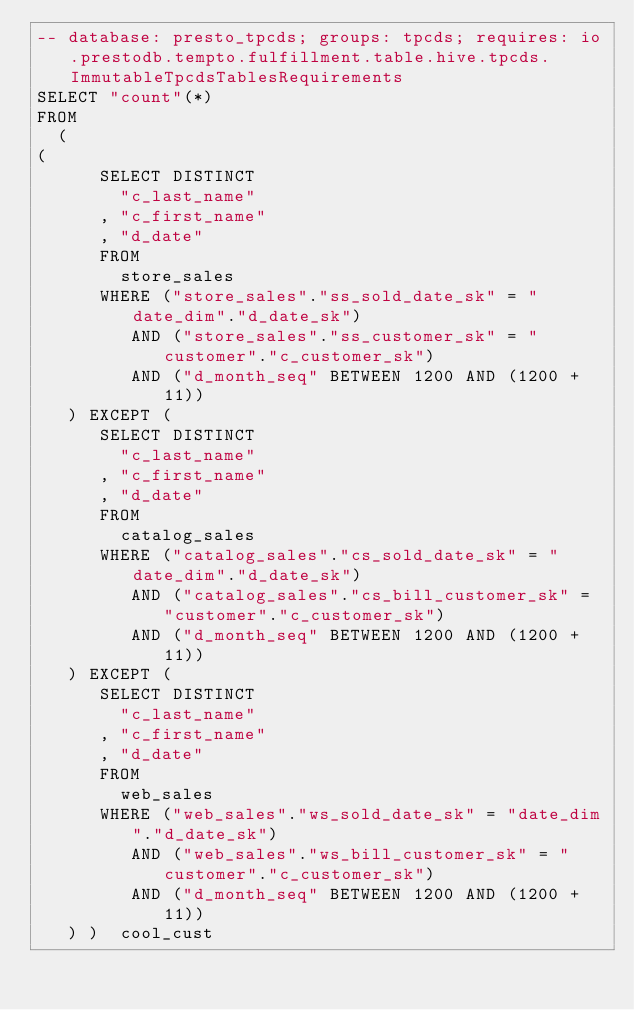Convert code to text. <code><loc_0><loc_0><loc_500><loc_500><_SQL_>-- database: presto_tpcds; groups: tpcds; requires: io.prestodb.tempto.fulfillment.table.hive.tpcds.ImmutableTpcdsTablesRequirements
SELECT "count"(*)
FROM
  (
(
      SELECT DISTINCT
        "c_last_name"
      , "c_first_name"
      , "d_date"
      FROM
        store_sales
      WHERE ("store_sales"."ss_sold_date_sk" = "date_dim"."d_date_sk")
         AND ("store_sales"."ss_customer_sk" = "customer"."c_customer_sk")
         AND ("d_month_seq" BETWEEN 1200 AND (1200 + 11))
   ) EXCEPT (
      SELECT DISTINCT
        "c_last_name"
      , "c_first_name"
      , "d_date"
      FROM
        catalog_sales
      WHERE ("catalog_sales"."cs_sold_date_sk" = "date_dim"."d_date_sk")
         AND ("catalog_sales"."cs_bill_customer_sk" = "customer"."c_customer_sk")
         AND ("d_month_seq" BETWEEN 1200 AND (1200 + 11))
   ) EXCEPT (
      SELECT DISTINCT
        "c_last_name"
      , "c_first_name"
      , "d_date"
      FROM
        web_sales
      WHERE ("web_sales"."ws_sold_date_sk" = "date_dim"."d_date_sk")
         AND ("web_sales"."ws_bill_customer_sk" = "customer"."c_customer_sk")
         AND ("d_month_seq" BETWEEN 1200 AND (1200 + 11))
   ) )  cool_cust
</code> 